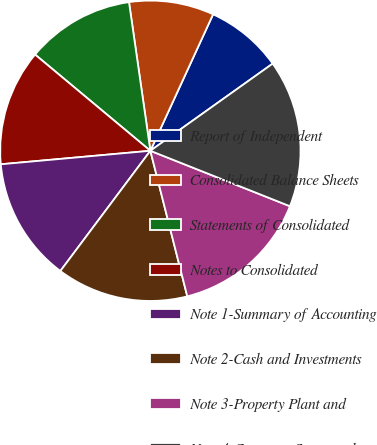Convert chart. <chart><loc_0><loc_0><loc_500><loc_500><pie_chart><fcel>Report of Independent<fcel>Consolidated Balance Sheets<fcel>Statements of Consolidated<fcel>Notes to Consolidated<fcel>Note 1-Summary of Accounting<fcel>Note 2-Cash and Investments<fcel>Note 3-Property Plant and<fcel>Note 4-Company-Sponsored<nl><fcel>8.29%<fcel>9.13%<fcel>11.66%<fcel>12.5%<fcel>13.34%<fcel>14.18%<fcel>15.03%<fcel>15.87%<nl></chart> 